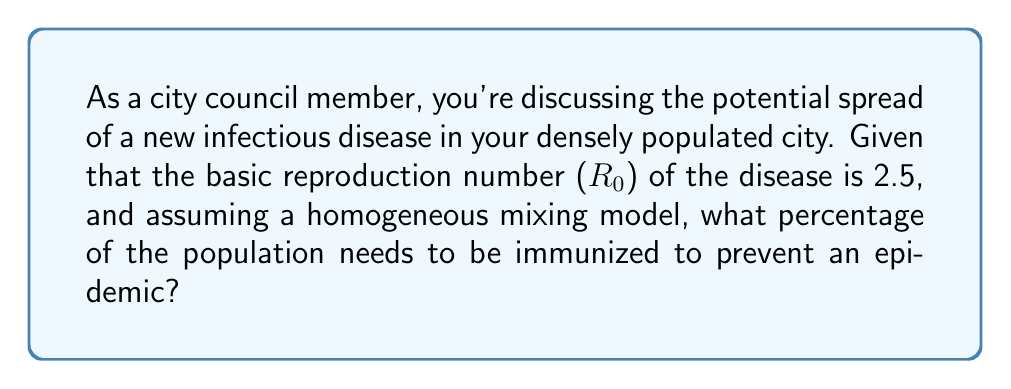Help me with this question. To solve this problem, we need to understand the concept of herd immunity threshold and its relationship to the basic reproduction number ($R_0$).

1. The basic reproduction number ($R_0$) represents the average number of secondary infections caused by one infected individual in a completely susceptible population.

2. The herd immunity threshold (HIT) is the proportion of the population that needs to be immune to prevent sustained disease spread.

3. The relationship between $R_0$ and HIT is given by the formula:

   $$ \text{HIT} = 1 - \frac{1}{R_0} $$

4. In this case, $R_0 = 2.5$. Let's substitute this into the formula:

   $$ \text{HIT} = 1 - \frac{1}{2.5} $$

5. Simplifying:
   $$ \text{HIT} = 1 - 0.4 = 0.6 $$

6. To express this as a percentage, we multiply by 100:

   $$ \text{HIT} = 0.6 \times 100 = 60\% $$

Therefore, 60% of the population needs to be immunized to prevent an epidemic in this scenario.
Answer: 60% 